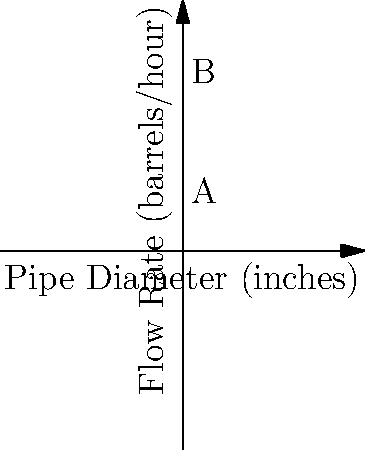The graph shows the relationship between pipe diameter and oil flow rate in your pipeline network. If the flow rate through a 2-inch diameter pipe (point A) is 4,000 barrels per hour, what is the expected flow rate through a 4-inch diameter pipe (point B)? To solve this problem, we need to understand the relationship between pipe diameter and flow rate:

1. Observe that the graph shows a quadratic relationship (parabolic curve).
2. The flow rate is proportional to the square of the diameter: $Q \propto d^2$

3. Let's call the flow rate $Q$ and the diameter $d$. We can write:
   $Q_1 = k d_1^2$ and $Q_2 = k d_2^2$, where $k$ is a constant.

4. We know $Q_1 = 4,000$ barrels/hour when $d_1 = 2$ inches.
   We want to find $Q_2$ when $d_2 = 4$ inches.

5. We can set up a proportion:
   $\frac{Q_1}{d_1^2} = \frac{Q_2}{d_2^2}$

6. Substituting the known values:
   $\frac{4,000}{2^2} = \frac{Q_2}{4^2}$

7. Simplifying:
   $\frac{4,000}{4} = \frac{Q_2}{16}$
   $1,000 = \frac{Q_2}{16}$

8. Solving for $Q_2$:
   $Q_2 = 1,000 * 16 = 16,000$ barrels/hour

Therefore, the expected flow rate through the 4-inch diameter pipe is 16,000 barrels per hour.
Answer: 16,000 barrels/hour 